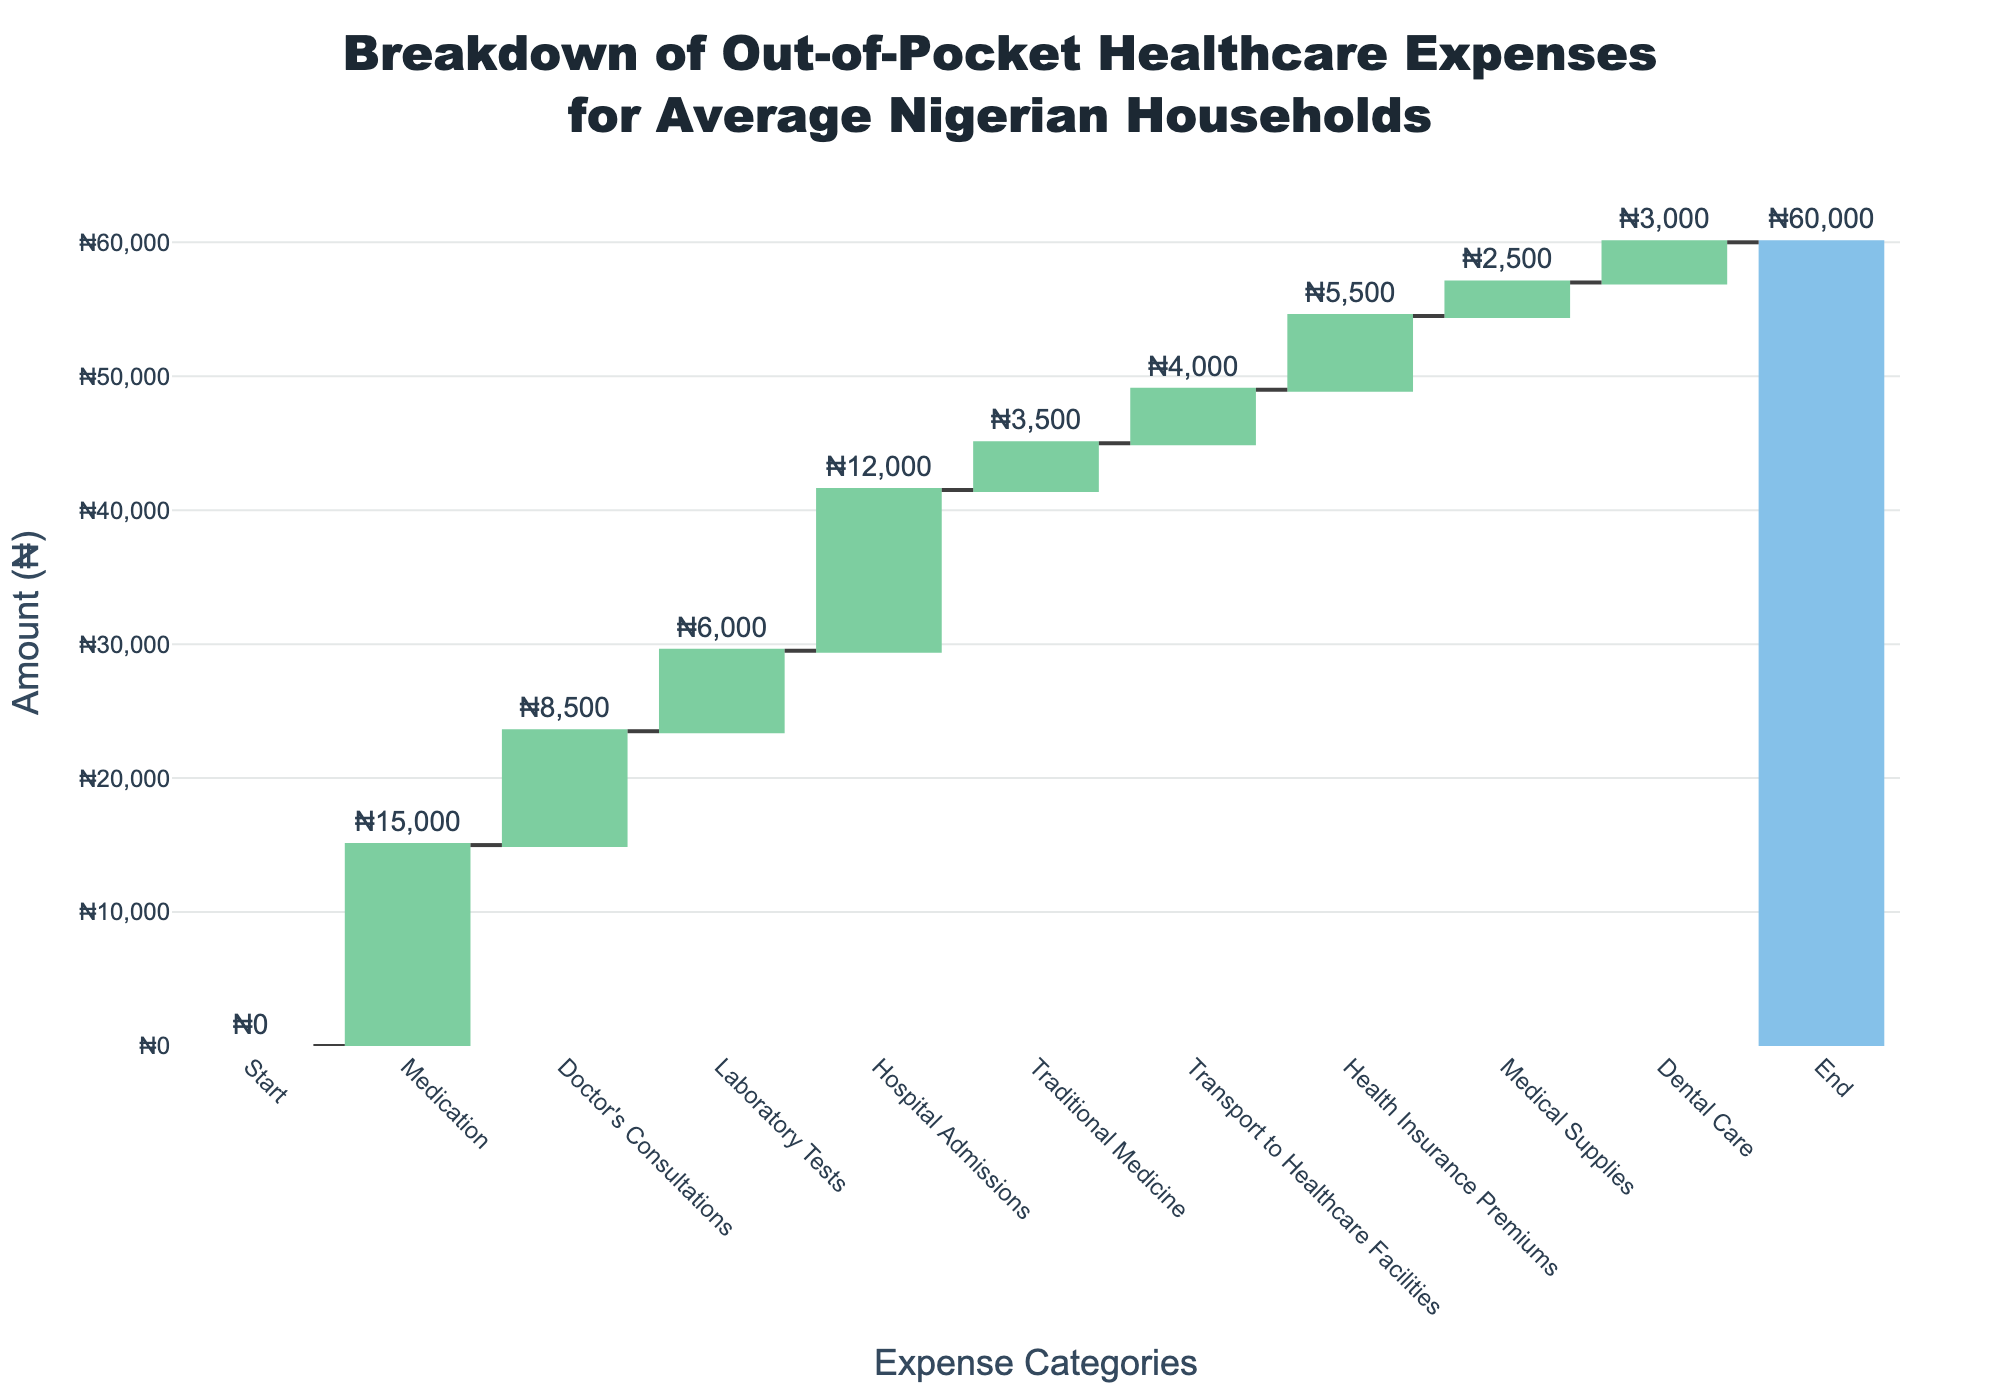What is the title of the chart? The title of the chart is usually displayed at the top, above the plot area.
Answer: Breakdown of Out-of-Pocket Healthcare Expenses for Average Nigerian Households How many expense categories are listed in the waterfall chart? To determine this, count each distinct category appearing along the x-axis.
Answer: 10 What is the amount spent on Doctor's Consultations? Look for the data point labeled "Doctor's Consultations" and read the corresponding value.
Answer: ₦8,500 Which expense category has the highest amount? Compare the values of each category to determine the highest one.
Answer: Medication How much more is spent on Medication compared to Laboratory Tests? Identify the amounts for both Medication (₦15,000) and Laboratory Tests (₦6,000), then subtract the latter from the former.
Answer: ₦9,000 If you combine the spending on Hospital Admissions and Health Insurance Premiums, what is the total? Add the values of Hospital Admissions (₦12,000) and Health Insurance Premiums (₦5,500).
Answer: ₦17,500 Which expense category has the lowest amount? Compare the values of each category to find the smallest one.
Answer: Medical Supplies How does the spending on Transport to Healthcare Facilities compare to Traditional Medicine? Identify the values for Transport to Healthcare Facilities (₦4,000) and Traditional Medicine (₦3,500), then determine which is greater.
Answer: Transport to Healthcare Facilities What is the total amount spent after accounting for all the expenses except for the final total in the chart? Sum all amounts from the categories excluding the final "End" value, which is not part of the expenses listed. Calculation: ₦15,000 + ₦8,500 + ₦6,000 + ₦12,000 + ₦3,500 + ₦4,000 + ₦5,500 + ₦2,500 + ₦3,000 = ₦60,000.
Answer: ₦60,000 What percentage of the total out-of-pocket expenses does the spending on Dental Care represent? Calculate the percentage as follows: (Dental Care amount / Total amount) * 100. In this case, (₦3,000 / ₦60,000) * 100 = 5%.
Answer: 5% 